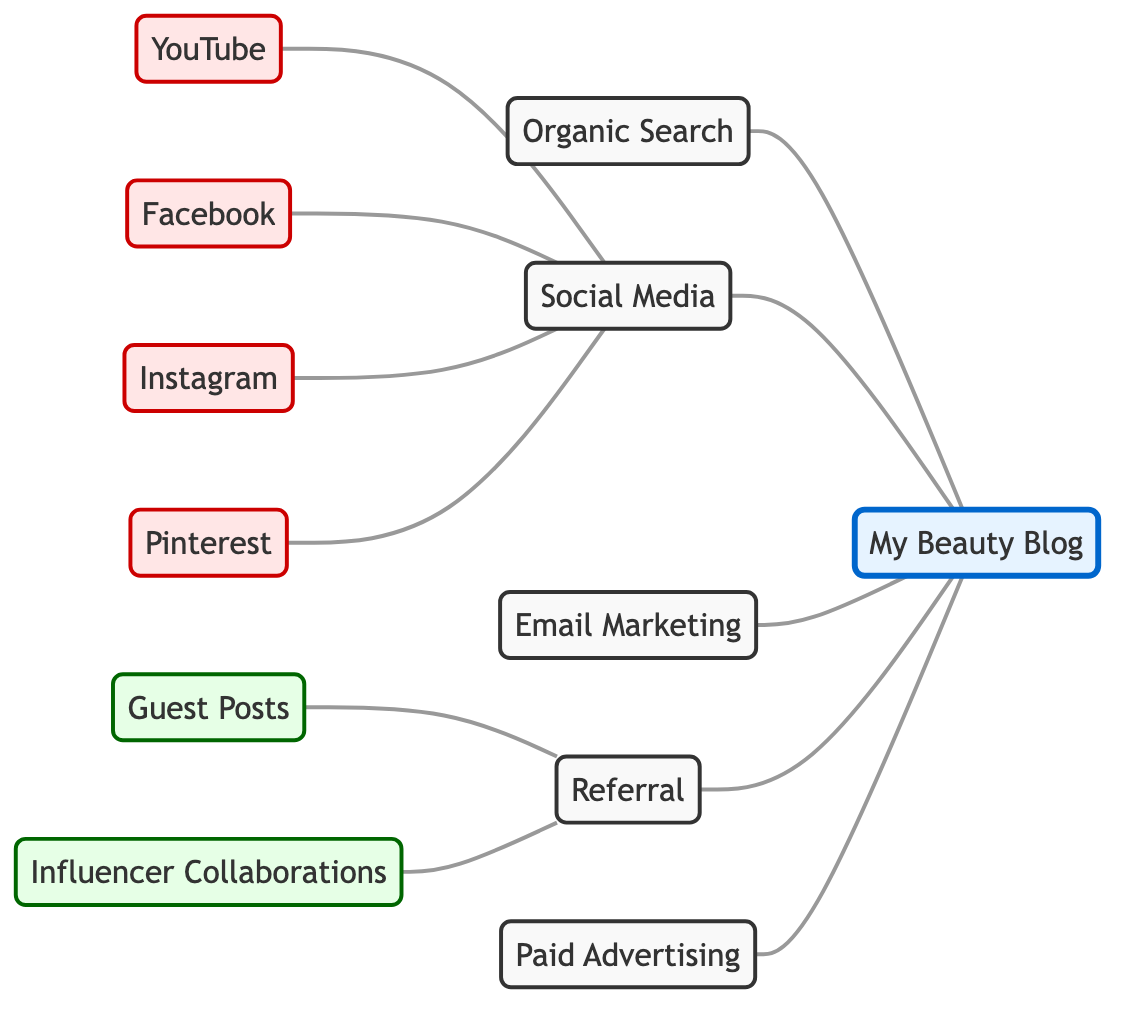What's the total number of nodes in the diagram? To find the total number of nodes, we can count each unique source and the blog itself. The nodes in the diagram are: My Beauty Blog, Organic Search, Social Media, Email Marketing, Referral, Paid Advertising, YouTube, Facebook, Instagram, Pinterest, Guest Posts, and Influencer Collaborations. Count gives us 12 nodes.
Answer: 12 Which nodes directly connect to 'My Beauty Blog'? We look at the edges connected to the node 'My Beauty Blog'. The nodes that connect directly to the blog are: Organic Search, Social Media, Email Marketing, Referral, and Paid Advertising. There are five direct connections.
Answer: 5 What is the relationship between 'YouTube' and 'Social Media'? The edge connecting 'YouTube' to 'Social Media' indicates a direct connection where YouTube is a source of traffic through Social Media. There is a direct relationship.
Answer: Direct connection How many types of traffic sources are related to 'Social Media'? The nodes that connect to 'Social Media' are YouTube, Facebook, Instagram, and Pinterest. By counting these, we see there are four sources of traffic that relate to Social Media.
Answer: 4 Which node acts as a source of traffic to 'Referral'? The node that connects directly to 'Referral' is Guest Posts and Influencer Collaborations. We see two nodes contributing as sources of traffic to Referral from the diagram.
Answer: 2 Which type of marketing is suggested by the 'Paid Advertising' node? The diagram shows the 'Paid Advertising' node connecting directly to 'My Beauty Blog', indicating that it's a source of traffic for the blog. The nature of this suggests it is an advertising type of marketing.
Answer: Advertising How do 'Guest Posts' and 'Influencer Collaborations' relate to 'My Beauty Blog'? Both Guest Posts and Influencer Collaborations connect to 'Referral', which in turn connects to 'My Beauty Blog'. Thus, they contribute to traffic indirectly through Referral.
Answer: Indirectly through Referral What is the main marketing channel that connects to 'My Beauty Blog'? By analyzing the connections, we can state the main marketing channels that connect directly to 'My Beauty Blog' are Organic Search, Social Media, Email Marketing, Referral, and Paid Advertising. This identifies five main channels contributing to traffic.
Answer: 5 